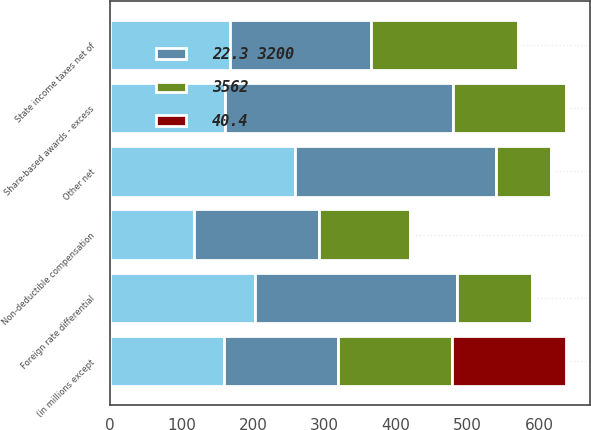Convert chart. <chart><loc_0><loc_0><loc_500><loc_500><stacked_bar_chart><ecel><fcel>(in millions except<fcel>State income taxes net of<fcel>Share-based awards - excess<fcel>Non-deductible compensation<fcel>Foreign rate differential<fcel>Other net<nl><fcel>nan<fcel>159.5<fcel>168<fcel>161<fcel>117<fcel>203<fcel>259<nl><fcel>40.4<fcel>159.5<fcel>1<fcel>1<fcel>0.7<fcel>1.3<fcel>1.6<nl><fcel>22.3 3200<fcel>159.5<fcel>197<fcel>319<fcel>175<fcel>282<fcel>280<nl><fcel>3562<fcel>159.5<fcel>205<fcel>158<fcel>128<fcel>105<fcel>77<nl></chart> 